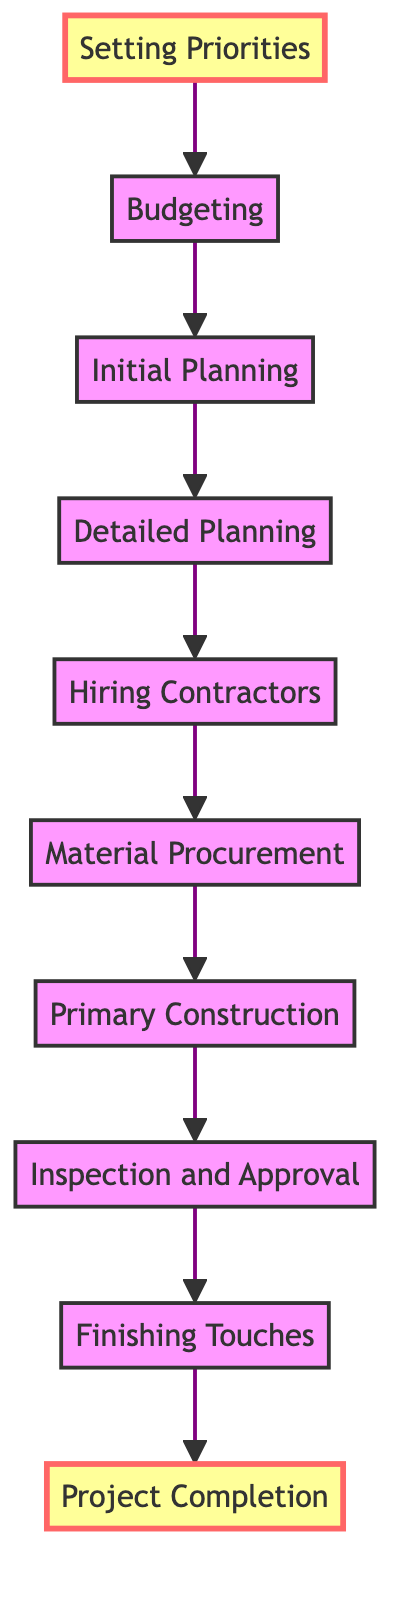What is the first step in the project? The diagram indicates that "Setting Priorities" is at the bottom, which means it is the first step in the flow of the project.
Answer: Setting Priorities How many total steps are in the diagram? Counting from "Setting Priorities" to "Project Completion," there are 10 nodes represented in the diagram.
Answer: 10 What is the last step in the project? The diagram shows "Project Completion" at the top, indicating it is the final step once all preceding tasks are completed.
Answer: Project Completion Which step comes immediately before “Finishing Touches”? According to the diagram, "Inspection and Approval" is directly connected below "Finishing Touches," meaning it precedes the completion of finishing tasks.
Answer: Inspection and Approval What are the two steps immediately following “Detailed Planning”? The flow shows that after "Detailed Planning," the next two steps are "Hiring Contractors" and then "Material Procurement."
Answer: Hiring Contractors, Material Procurement What is the relationship between “Material Procurement” and “Primary Construction”? The flow indicates a direct progression from "Material Procurement" to "Primary Construction," signifying that material procurement must occur before primary construction can begin.
Answer: Material Procurement leads to Primary Construction What step includes hiring for specialized tasks? The diagram specifies that "Hiring Contractors" is the step focused on selecting and employing specialists, particularly for tasks like plumbing and electrical work.
Answer: Hiring Contractors At which step do you determine the overall budget? "Budgeting" is identified as the step where the overall project budget is decided, including funds set aside for unexpected costs.
Answer: Budgeting Which steps are marked as highlights in the diagram? The start and end steps, "Setting Priorities" and "Project Completion," are marked as highlights, indicating their importance in the flow of the project.
Answer: Setting Priorities, Project Completion How many steps are there between "Initial Planning" and "Inspection and Approval"? The flow connects "Initial Planning" to "Inspection and Approval" through four intermediate steps: "Detailed Planning," "Hiring Contractors," "Material Procurement," and "Primary Construction." This sums up to a total of four steps in between.
Answer: 4 